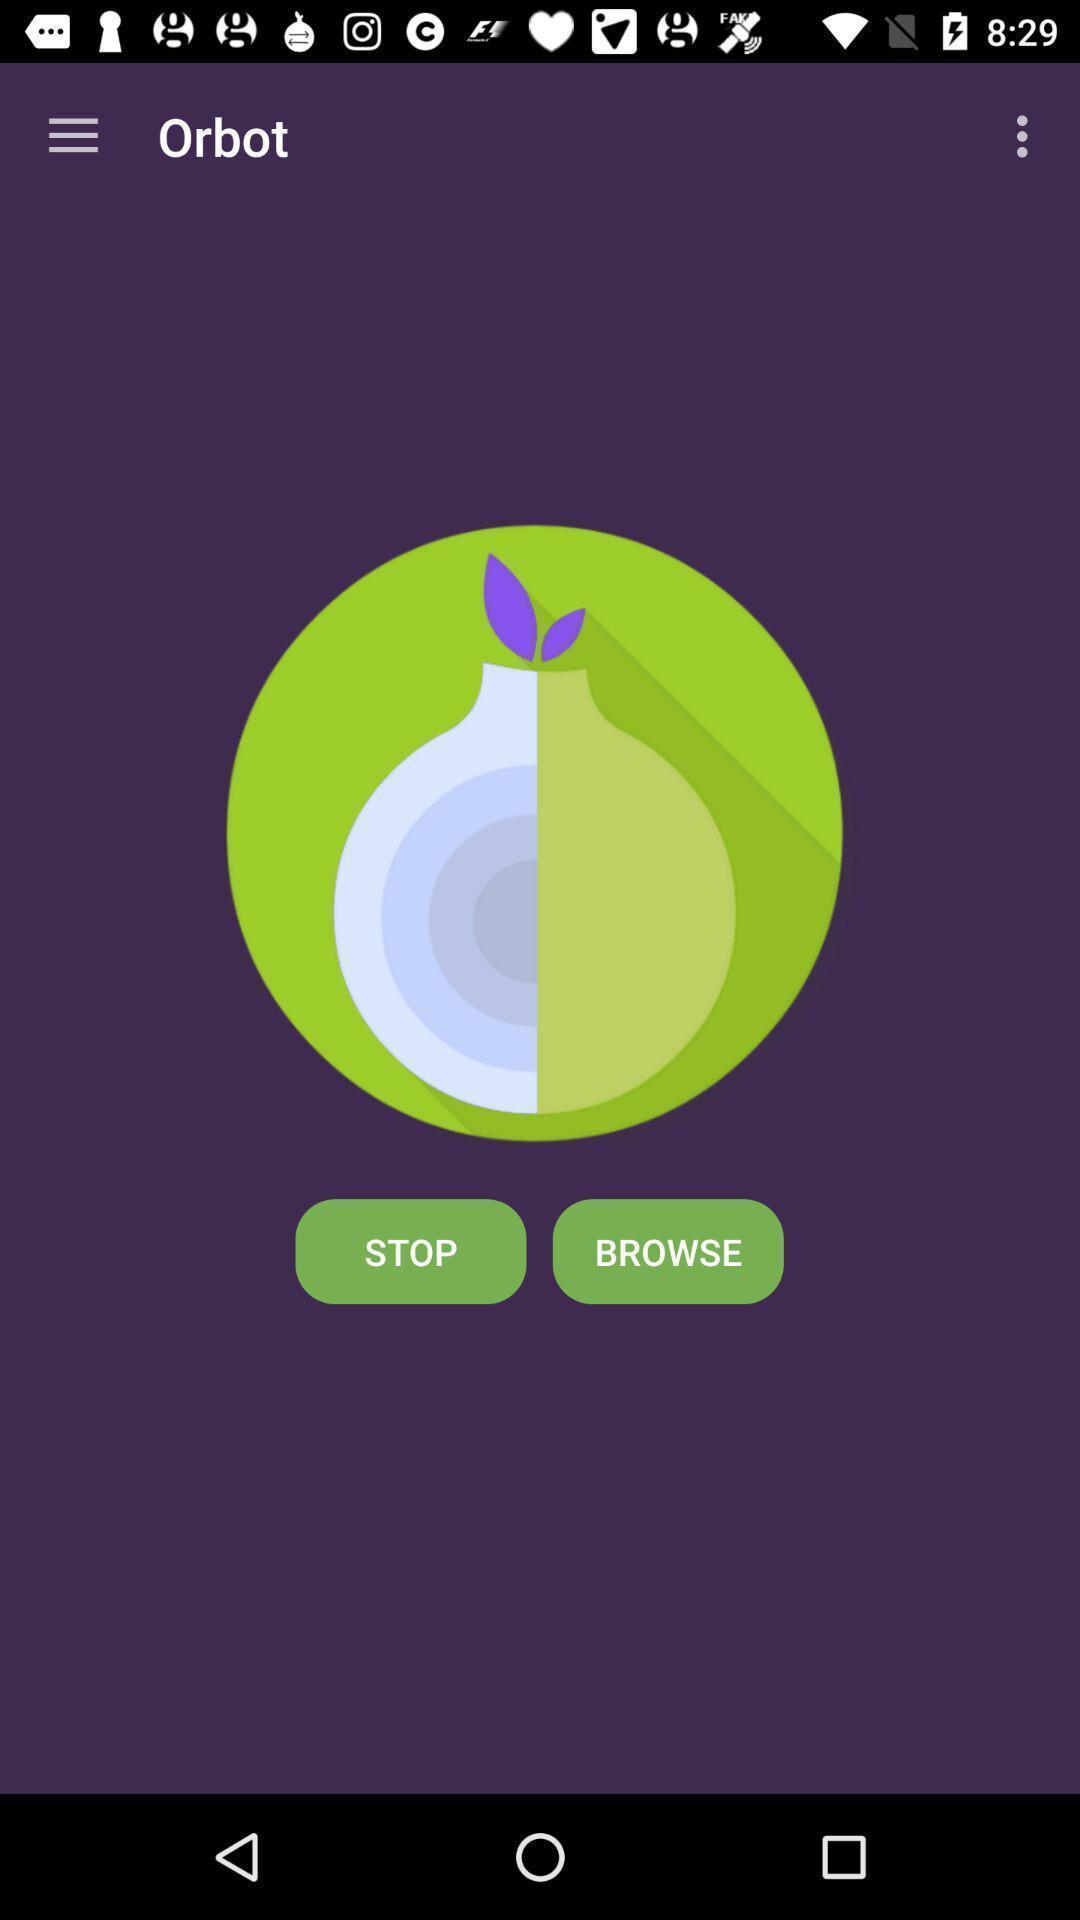Describe the content in this image. Window displaying a app which is secure. 